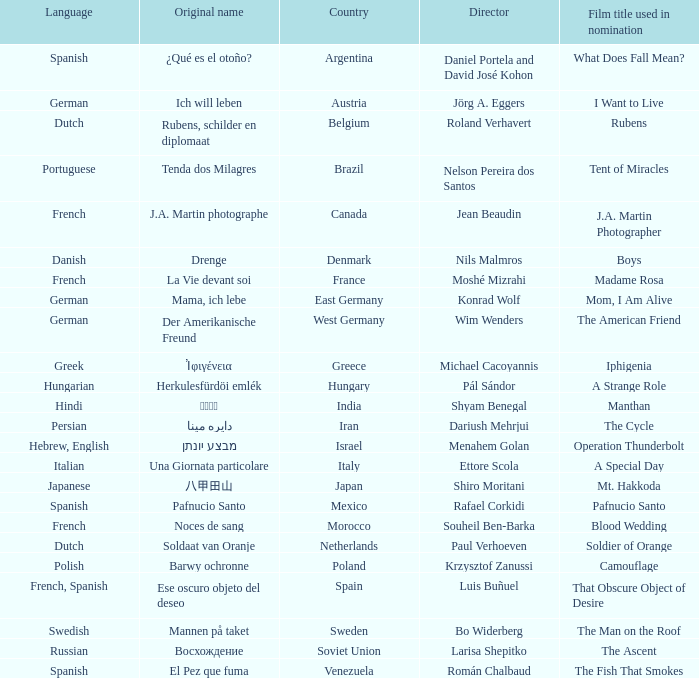What is the title of the German film that is originally called Mama, Ich Lebe? Mom, I Am Alive. 